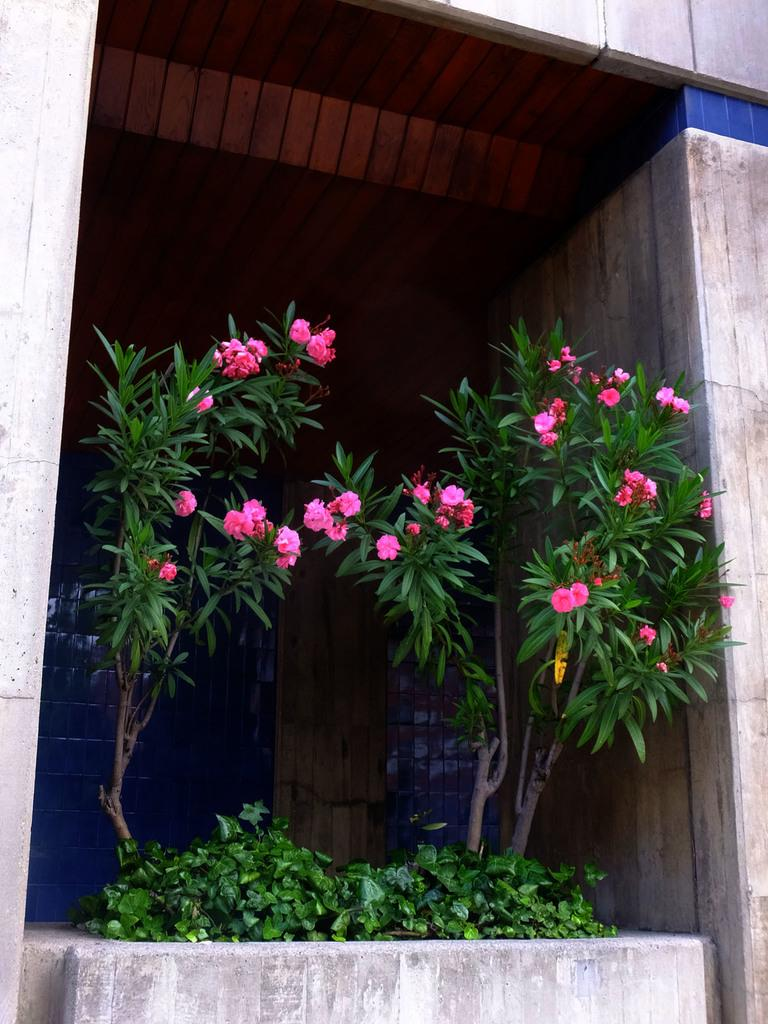What type of structure is visible in the image? There is a building in the image. What type of vegetation can be seen in the image? There are plants with flowers in the image. What color is the pot in the middle of the image? There is no pot present in the image. How many eyes can be seen on the flowers in the image? Flowers do not have eyes, so this question cannot be answered. 